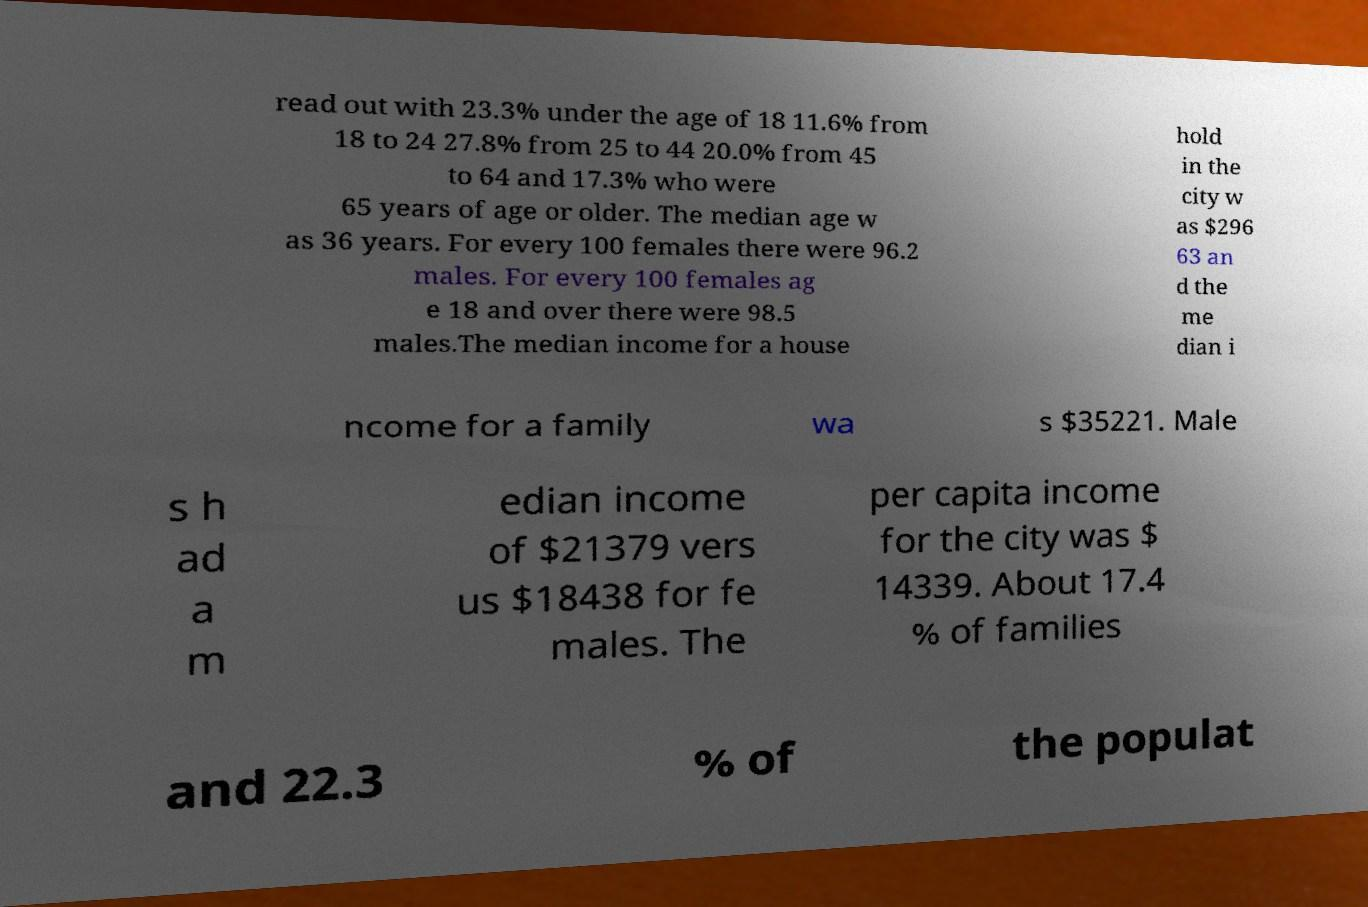Please identify and transcribe the text found in this image. read out with 23.3% under the age of 18 11.6% from 18 to 24 27.8% from 25 to 44 20.0% from 45 to 64 and 17.3% who were 65 years of age or older. The median age w as 36 years. For every 100 females there were 96.2 males. For every 100 females ag e 18 and over there were 98.5 males.The median income for a house hold in the city w as $296 63 an d the me dian i ncome for a family wa s $35221. Male s h ad a m edian income of $21379 vers us $18438 for fe males. The per capita income for the city was $ 14339. About 17.4 % of families and 22.3 % of the populat 